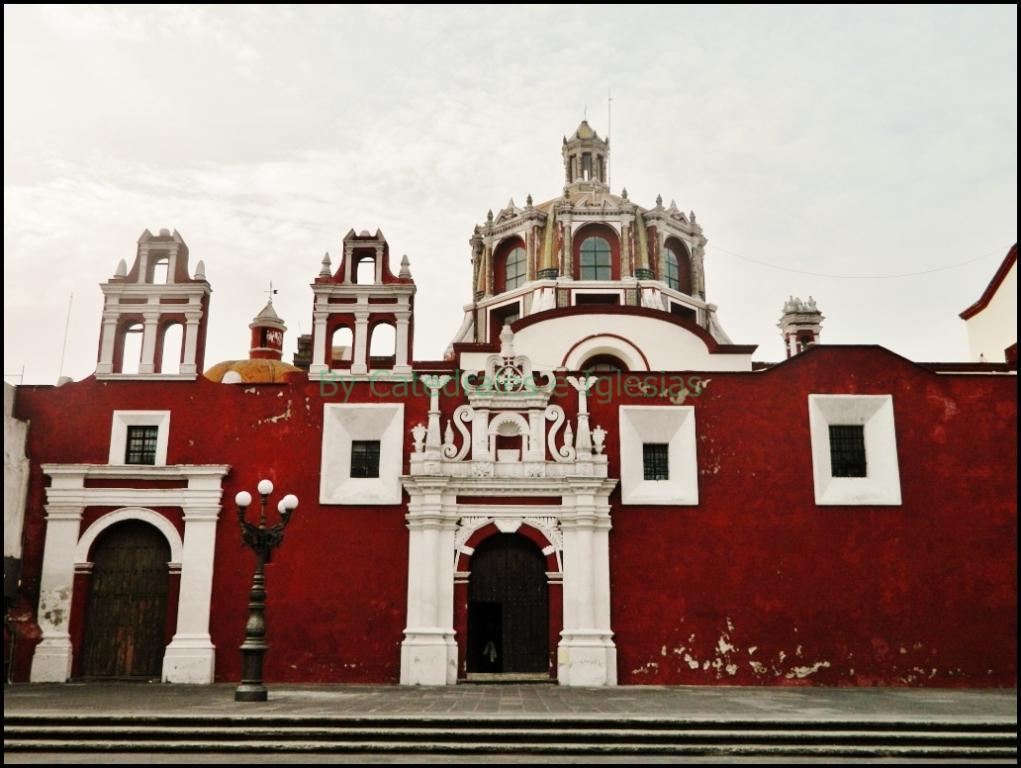What type of building is shown in the image? The image appears to depict a palace. What architectural feature is located in front of the palace? There are steps in front of the palace. What is attached to the pole on the steps? Lights are attached to the pole on the steps. What can be seen at the top of the image? The sky is visible at the top of the image. Where can one find a store selling guidebooks about the palace in the image? There is no store or guidebooks mentioned or depicted in the image. 